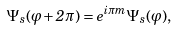<formula> <loc_0><loc_0><loc_500><loc_500>\Psi _ { s } ( \varphi + 2 \pi ) = e ^ { i \pi m } \Psi _ { s } ( \varphi ) ,</formula> 